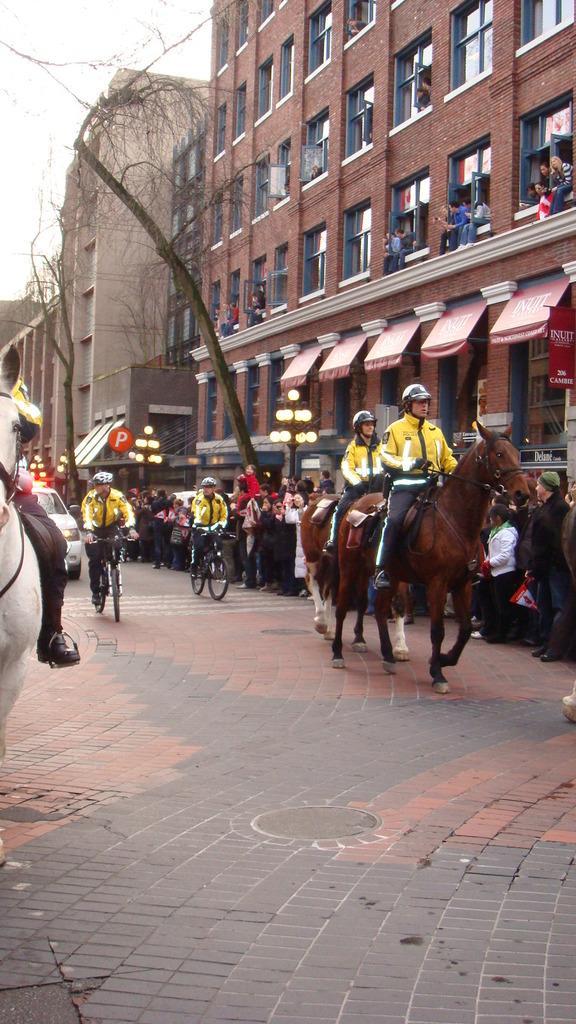Could you give a brief overview of what you see in this image? These are buildings. In-front of this building there is a bare tree. These two persons are sitting on horse. Far this group of people are standing and this two persons are riding a bicycle. A vehicle on road. 